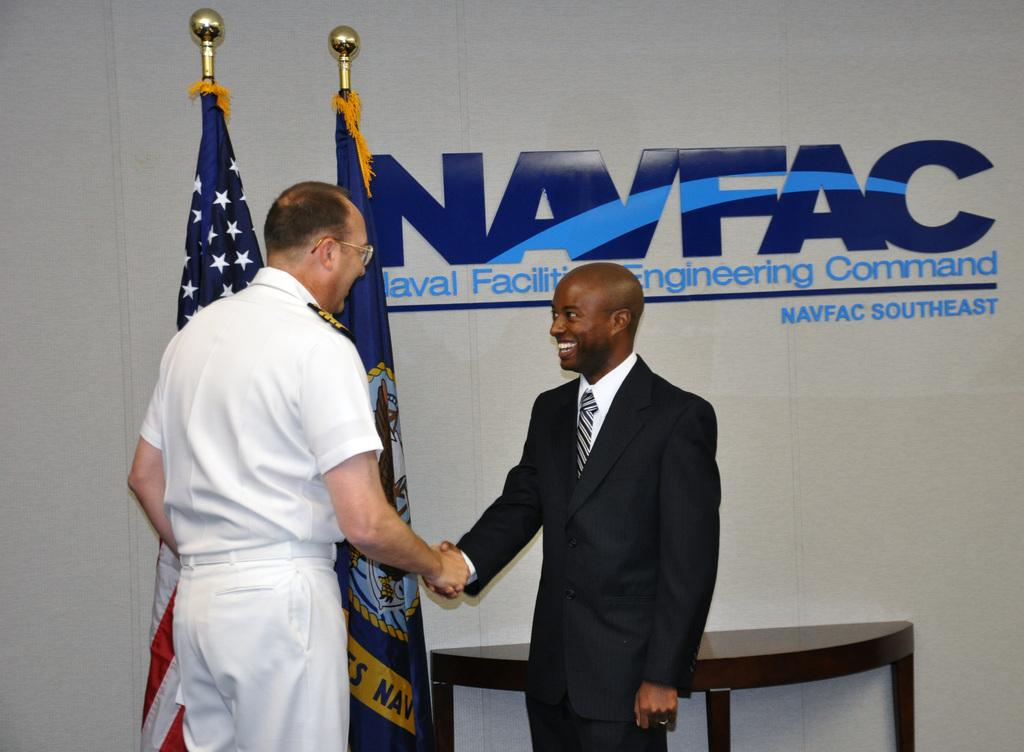<image>
Offer a succinct explanation of the picture presented. a couple men shaking hands with a NAVFAC sign behind them 